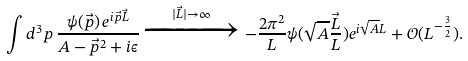Convert formula to latex. <formula><loc_0><loc_0><loc_500><loc_500>\int d ^ { 3 } p \, \frac { \psi ( \vec { p } ) \, e ^ { i \vec { p } \vec { L } } } { A - \vec { p } ^ { 2 } + i \epsilon } \xrightarrow { | \vec { L } | \rightarrow \infty } - \frac { 2 \pi ^ { 2 } } { L } \psi ( \sqrt { A } \frac { \vec { L } } { L } ) e ^ { i \sqrt { A } L } + \mathcal { O } ( L ^ { - \frac { 3 } { 2 } } ) .</formula> 